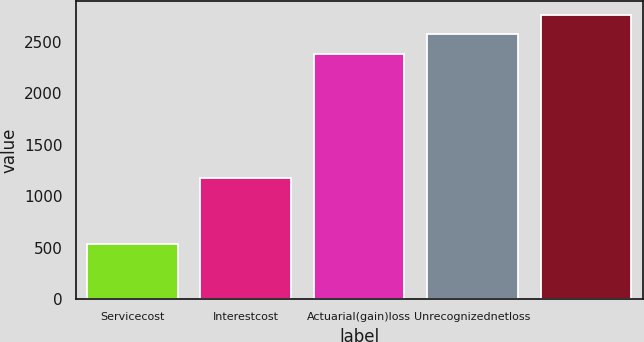Convert chart to OTSL. <chart><loc_0><loc_0><loc_500><loc_500><bar_chart><fcel>Servicecost<fcel>Interestcost<fcel>Actuarial(gain)loss<fcel>Unrecognizednetloss<fcel>Unnamed: 4<nl><fcel>532<fcel>1175<fcel>2380<fcel>2568.8<fcel>2757.6<nl></chart> 